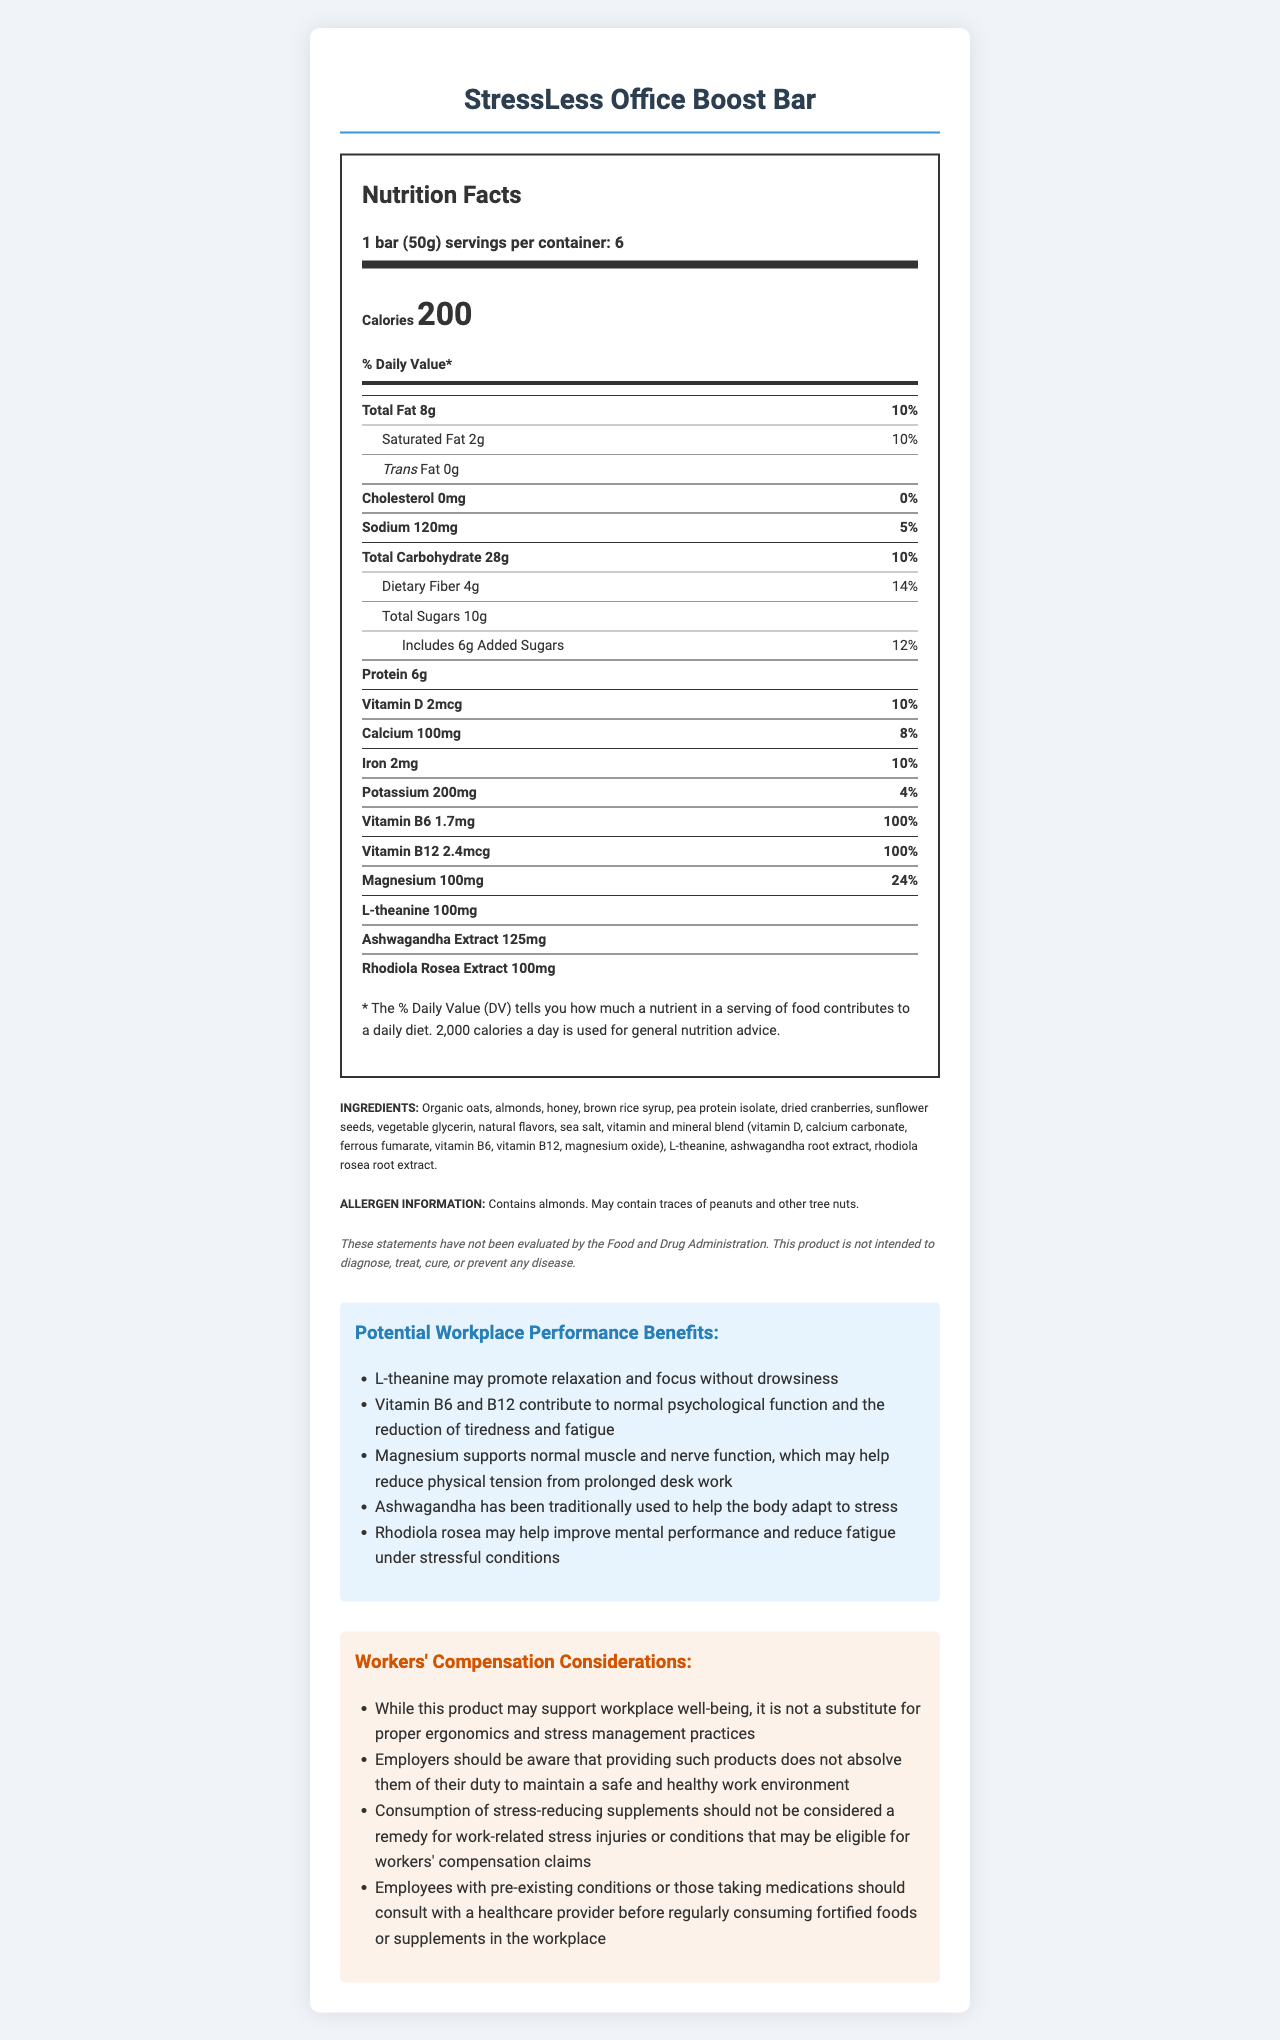what is the serving size of the StressLess Office Boost Bar? The serving size is clearly stated as "1 bar (50g)" in the document.
Answer: 1 bar (50g) how many calories are in one serving of the StressLess Office Boost Bar? The document specifies that one serving contains 200 calories.
Answer: 200 what is the percentage daily value of magnesium in one StressLess Office Boost Bar? The document lists magnesium as having 100mg, which is 24% of the daily value.
Answer: 24% how many servings are there per container? The document details that there are 6 servings per container.
Answer: 6 which ingredient is specifically mentioned as potentially causing allergies? Under the allergen information, it is stated that the product contains almonds and may contain traces of peanuts and other tree nuts.
Answer: almonds which vitamin has the highest percentage daily value in the StressLess Office Boost Bar? A. Vitamin D B. Vitamin B6 C. Vitamin B12 D. Calcium The document states that Vitamin B12 has 100% daily value, which is the highest among the listed vitamins and minerals.
Answer: C. Vitamin B12 what is the primary nutrient not included in the daily value percentages? A. Total Sugars B. Protein C. Ashwagandha Extract D. Trans Fat Ashwagandha Extract is listed in the nutrients but does not have a daily value percentage listed.
Answer: C. Ashwagandha Extract is the StressLess Office Boost Bar intended to diagnose, treat, cure, or prevent any disease? The legal disclaimer states that the product is not intended to diagnose, treat, cure, or prevent any disease.
Answer: No summarize the primary benefits and considerations provided by the StressLess Office Boost Bar in the workplace. This summary encapsulates the main claims about workplace performance benefits and the important considerations regarding workers' compensation and health advice.
Answer: The StressLess Office Boost Bar is marketed as having stress-reducing ingredients like L-theanine, ashwagandha extract, and rhodiola rosea extract, which may improve focus, reduce fatigue, and help with stress adaptation. However, it is not a substitute for proper ergonomics and stress management practices and should not be considered a remedy for work-related stress injuries. Employees should consult with healthcare providers before regular consumption, especially if they have pre-existing conditions or are on medications. does the StressLess Office Boost Bar contain any trans fat? The document clearly states that the bar contains 0g of trans fat.
Answer: No what is the potential workplace performance benefit of L-theanine? One of the workplace performance claims is that L-theanine may promote relaxation and focus without causing drowsiness.
Answer: promotes relaxation and focus without drowsiness can the document provide detailed scientific studies supporting the claims made? The document lists potential benefits but does not provide detailed scientific references or studies to support these claims.
Answer: Not enough information what is the role of vitamin B6 in the StressLess Office Boost Bar according to the document? The document claims that Vitamin B6 contributes to normal psychological function and helps reduce tiredness and fatigue.
Answer: contributes to normal psychological function and the reduction of tiredness and fatigue 